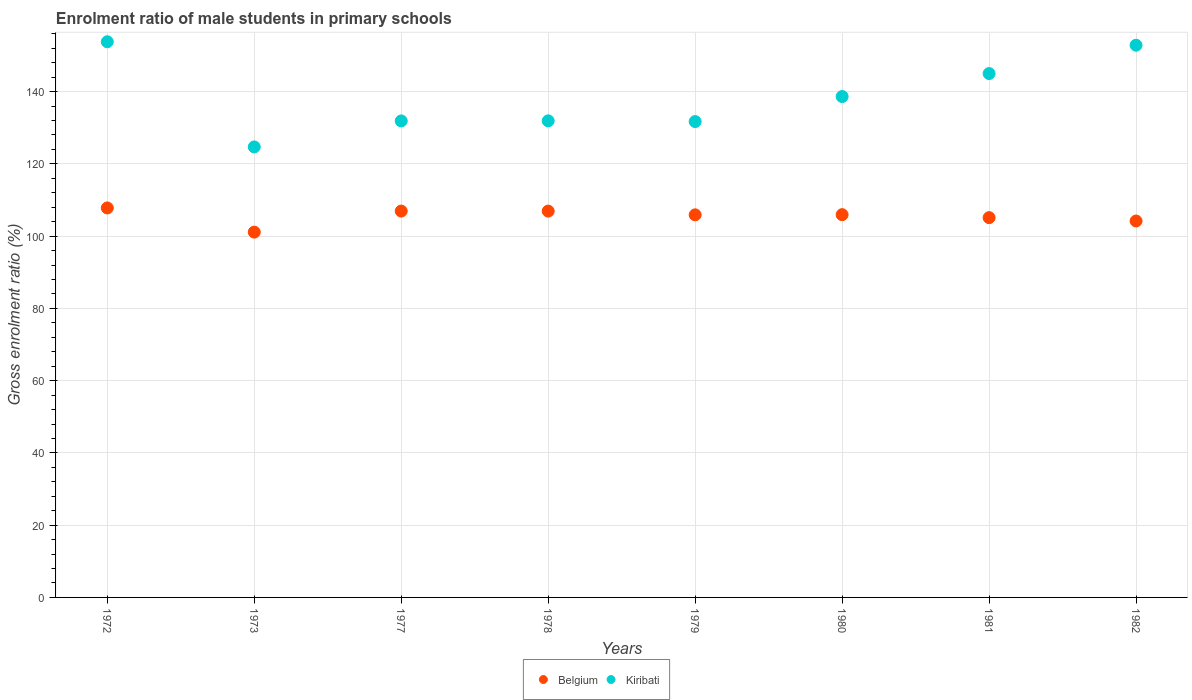How many different coloured dotlines are there?
Offer a very short reply. 2. What is the enrolment ratio of male students in primary schools in Belgium in 1980?
Your answer should be compact. 105.94. Across all years, what is the maximum enrolment ratio of male students in primary schools in Kiribati?
Your response must be concise. 153.8. Across all years, what is the minimum enrolment ratio of male students in primary schools in Belgium?
Keep it short and to the point. 101.11. In which year was the enrolment ratio of male students in primary schools in Belgium minimum?
Your response must be concise. 1973. What is the total enrolment ratio of male students in primary schools in Kiribati in the graph?
Make the answer very short. 1110.47. What is the difference between the enrolment ratio of male students in primary schools in Belgium in 1978 and that in 1980?
Ensure brevity in your answer.  0.99. What is the difference between the enrolment ratio of male students in primary schools in Kiribati in 1979 and the enrolment ratio of male students in primary schools in Belgium in 1981?
Keep it short and to the point. 26.59. What is the average enrolment ratio of male students in primary schools in Kiribati per year?
Your response must be concise. 138.81. In the year 1978, what is the difference between the enrolment ratio of male students in primary schools in Belgium and enrolment ratio of male students in primary schools in Kiribati?
Make the answer very short. -24.98. What is the ratio of the enrolment ratio of male students in primary schools in Kiribati in 1972 to that in 1973?
Provide a succinct answer. 1.23. What is the difference between the highest and the second highest enrolment ratio of male students in primary schools in Kiribati?
Offer a terse response. 0.95. What is the difference between the highest and the lowest enrolment ratio of male students in primary schools in Kiribati?
Make the answer very short. 29.11. In how many years, is the enrolment ratio of male students in primary schools in Belgium greater than the average enrolment ratio of male students in primary schools in Belgium taken over all years?
Your answer should be compact. 5. Is the sum of the enrolment ratio of male students in primary schools in Belgium in 1980 and 1981 greater than the maximum enrolment ratio of male students in primary schools in Kiribati across all years?
Offer a very short reply. Yes. Does the enrolment ratio of male students in primary schools in Belgium monotonically increase over the years?
Provide a short and direct response. No. Is the enrolment ratio of male students in primary schools in Belgium strictly greater than the enrolment ratio of male students in primary schools in Kiribati over the years?
Your response must be concise. No. Are the values on the major ticks of Y-axis written in scientific E-notation?
Make the answer very short. No. How many legend labels are there?
Your response must be concise. 2. What is the title of the graph?
Keep it short and to the point. Enrolment ratio of male students in primary schools. What is the label or title of the X-axis?
Provide a short and direct response. Years. What is the label or title of the Y-axis?
Keep it short and to the point. Gross enrolment ratio (%). What is the Gross enrolment ratio (%) in Belgium in 1972?
Provide a short and direct response. 107.8. What is the Gross enrolment ratio (%) in Kiribati in 1972?
Provide a succinct answer. 153.8. What is the Gross enrolment ratio (%) in Belgium in 1973?
Offer a very short reply. 101.11. What is the Gross enrolment ratio (%) of Kiribati in 1973?
Your answer should be compact. 124.69. What is the Gross enrolment ratio (%) of Belgium in 1977?
Ensure brevity in your answer.  106.93. What is the Gross enrolment ratio (%) of Kiribati in 1977?
Give a very brief answer. 131.89. What is the Gross enrolment ratio (%) of Belgium in 1978?
Offer a terse response. 106.92. What is the Gross enrolment ratio (%) of Kiribati in 1978?
Your answer should be very brief. 131.91. What is the Gross enrolment ratio (%) in Belgium in 1979?
Your answer should be very brief. 105.89. What is the Gross enrolment ratio (%) of Kiribati in 1979?
Provide a short and direct response. 131.71. What is the Gross enrolment ratio (%) of Belgium in 1980?
Give a very brief answer. 105.94. What is the Gross enrolment ratio (%) in Kiribati in 1980?
Ensure brevity in your answer.  138.64. What is the Gross enrolment ratio (%) of Belgium in 1981?
Keep it short and to the point. 105.12. What is the Gross enrolment ratio (%) of Kiribati in 1981?
Give a very brief answer. 145. What is the Gross enrolment ratio (%) of Belgium in 1982?
Provide a succinct answer. 104.19. What is the Gross enrolment ratio (%) of Kiribati in 1982?
Your answer should be very brief. 152.84. Across all years, what is the maximum Gross enrolment ratio (%) in Belgium?
Your response must be concise. 107.8. Across all years, what is the maximum Gross enrolment ratio (%) of Kiribati?
Your response must be concise. 153.8. Across all years, what is the minimum Gross enrolment ratio (%) of Belgium?
Make the answer very short. 101.11. Across all years, what is the minimum Gross enrolment ratio (%) of Kiribati?
Make the answer very short. 124.69. What is the total Gross enrolment ratio (%) in Belgium in the graph?
Offer a very short reply. 843.91. What is the total Gross enrolment ratio (%) of Kiribati in the graph?
Make the answer very short. 1110.47. What is the difference between the Gross enrolment ratio (%) in Belgium in 1972 and that in 1973?
Offer a very short reply. 6.69. What is the difference between the Gross enrolment ratio (%) in Kiribati in 1972 and that in 1973?
Give a very brief answer. 29.11. What is the difference between the Gross enrolment ratio (%) of Belgium in 1972 and that in 1977?
Offer a terse response. 0.87. What is the difference between the Gross enrolment ratio (%) in Kiribati in 1972 and that in 1977?
Give a very brief answer. 21.91. What is the difference between the Gross enrolment ratio (%) of Belgium in 1972 and that in 1978?
Provide a short and direct response. 0.88. What is the difference between the Gross enrolment ratio (%) of Kiribati in 1972 and that in 1978?
Provide a short and direct response. 21.89. What is the difference between the Gross enrolment ratio (%) of Belgium in 1972 and that in 1979?
Keep it short and to the point. 1.91. What is the difference between the Gross enrolment ratio (%) of Kiribati in 1972 and that in 1979?
Ensure brevity in your answer.  22.09. What is the difference between the Gross enrolment ratio (%) in Belgium in 1972 and that in 1980?
Your answer should be very brief. 1.86. What is the difference between the Gross enrolment ratio (%) in Kiribati in 1972 and that in 1980?
Your answer should be very brief. 15.16. What is the difference between the Gross enrolment ratio (%) in Belgium in 1972 and that in 1981?
Your answer should be very brief. 2.68. What is the difference between the Gross enrolment ratio (%) in Kiribati in 1972 and that in 1981?
Your answer should be very brief. 8.8. What is the difference between the Gross enrolment ratio (%) in Belgium in 1972 and that in 1982?
Ensure brevity in your answer.  3.61. What is the difference between the Gross enrolment ratio (%) in Belgium in 1973 and that in 1977?
Your answer should be very brief. -5.82. What is the difference between the Gross enrolment ratio (%) of Kiribati in 1973 and that in 1977?
Provide a succinct answer. -7.2. What is the difference between the Gross enrolment ratio (%) of Belgium in 1973 and that in 1978?
Provide a short and direct response. -5.81. What is the difference between the Gross enrolment ratio (%) in Kiribati in 1973 and that in 1978?
Ensure brevity in your answer.  -7.22. What is the difference between the Gross enrolment ratio (%) of Belgium in 1973 and that in 1979?
Give a very brief answer. -4.78. What is the difference between the Gross enrolment ratio (%) in Kiribati in 1973 and that in 1979?
Ensure brevity in your answer.  -7.02. What is the difference between the Gross enrolment ratio (%) of Belgium in 1973 and that in 1980?
Your answer should be compact. -4.83. What is the difference between the Gross enrolment ratio (%) of Kiribati in 1973 and that in 1980?
Your answer should be very brief. -13.95. What is the difference between the Gross enrolment ratio (%) of Belgium in 1973 and that in 1981?
Make the answer very short. -4.01. What is the difference between the Gross enrolment ratio (%) of Kiribati in 1973 and that in 1981?
Your response must be concise. -20.31. What is the difference between the Gross enrolment ratio (%) in Belgium in 1973 and that in 1982?
Your response must be concise. -3.08. What is the difference between the Gross enrolment ratio (%) in Kiribati in 1973 and that in 1982?
Offer a terse response. -28.15. What is the difference between the Gross enrolment ratio (%) of Belgium in 1977 and that in 1978?
Your response must be concise. 0.01. What is the difference between the Gross enrolment ratio (%) of Kiribati in 1977 and that in 1978?
Offer a terse response. -0.02. What is the difference between the Gross enrolment ratio (%) in Belgium in 1977 and that in 1979?
Give a very brief answer. 1.04. What is the difference between the Gross enrolment ratio (%) in Kiribati in 1977 and that in 1979?
Ensure brevity in your answer.  0.18. What is the difference between the Gross enrolment ratio (%) of Belgium in 1977 and that in 1980?
Your answer should be very brief. 1. What is the difference between the Gross enrolment ratio (%) in Kiribati in 1977 and that in 1980?
Give a very brief answer. -6.75. What is the difference between the Gross enrolment ratio (%) in Belgium in 1977 and that in 1981?
Your answer should be compact. 1.82. What is the difference between the Gross enrolment ratio (%) in Kiribati in 1977 and that in 1981?
Provide a short and direct response. -13.11. What is the difference between the Gross enrolment ratio (%) of Belgium in 1977 and that in 1982?
Provide a short and direct response. 2.74. What is the difference between the Gross enrolment ratio (%) in Kiribati in 1977 and that in 1982?
Your answer should be very brief. -20.95. What is the difference between the Gross enrolment ratio (%) in Belgium in 1978 and that in 1979?
Make the answer very short. 1.03. What is the difference between the Gross enrolment ratio (%) of Kiribati in 1978 and that in 1979?
Provide a succinct answer. 0.2. What is the difference between the Gross enrolment ratio (%) of Kiribati in 1978 and that in 1980?
Your answer should be very brief. -6.73. What is the difference between the Gross enrolment ratio (%) in Belgium in 1978 and that in 1981?
Offer a terse response. 1.81. What is the difference between the Gross enrolment ratio (%) of Kiribati in 1978 and that in 1981?
Your answer should be very brief. -13.09. What is the difference between the Gross enrolment ratio (%) of Belgium in 1978 and that in 1982?
Your answer should be very brief. 2.73. What is the difference between the Gross enrolment ratio (%) in Kiribati in 1978 and that in 1982?
Your response must be concise. -20.93. What is the difference between the Gross enrolment ratio (%) of Belgium in 1979 and that in 1980?
Your answer should be compact. -0.05. What is the difference between the Gross enrolment ratio (%) in Kiribati in 1979 and that in 1980?
Give a very brief answer. -6.93. What is the difference between the Gross enrolment ratio (%) in Belgium in 1979 and that in 1981?
Ensure brevity in your answer.  0.78. What is the difference between the Gross enrolment ratio (%) in Kiribati in 1979 and that in 1981?
Provide a short and direct response. -13.29. What is the difference between the Gross enrolment ratio (%) in Belgium in 1979 and that in 1982?
Provide a succinct answer. 1.7. What is the difference between the Gross enrolment ratio (%) of Kiribati in 1979 and that in 1982?
Your answer should be very brief. -21.13. What is the difference between the Gross enrolment ratio (%) of Belgium in 1980 and that in 1981?
Keep it short and to the point. 0.82. What is the difference between the Gross enrolment ratio (%) of Kiribati in 1980 and that in 1981?
Your answer should be very brief. -6.36. What is the difference between the Gross enrolment ratio (%) in Belgium in 1980 and that in 1982?
Make the answer very short. 1.75. What is the difference between the Gross enrolment ratio (%) of Kiribati in 1980 and that in 1982?
Your response must be concise. -14.21. What is the difference between the Gross enrolment ratio (%) of Belgium in 1981 and that in 1982?
Your response must be concise. 0.93. What is the difference between the Gross enrolment ratio (%) in Kiribati in 1981 and that in 1982?
Your response must be concise. -7.85. What is the difference between the Gross enrolment ratio (%) in Belgium in 1972 and the Gross enrolment ratio (%) in Kiribati in 1973?
Offer a terse response. -16.89. What is the difference between the Gross enrolment ratio (%) in Belgium in 1972 and the Gross enrolment ratio (%) in Kiribati in 1977?
Provide a succinct answer. -24.09. What is the difference between the Gross enrolment ratio (%) in Belgium in 1972 and the Gross enrolment ratio (%) in Kiribati in 1978?
Ensure brevity in your answer.  -24.11. What is the difference between the Gross enrolment ratio (%) in Belgium in 1972 and the Gross enrolment ratio (%) in Kiribati in 1979?
Offer a very short reply. -23.91. What is the difference between the Gross enrolment ratio (%) in Belgium in 1972 and the Gross enrolment ratio (%) in Kiribati in 1980?
Give a very brief answer. -30.84. What is the difference between the Gross enrolment ratio (%) of Belgium in 1972 and the Gross enrolment ratio (%) of Kiribati in 1981?
Your response must be concise. -37.2. What is the difference between the Gross enrolment ratio (%) of Belgium in 1972 and the Gross enrolment ratio (%) of Kiribati in 1982?
Provide a succinct answer. -45.04. What is the difference between the Gross enrolment ratio (%) of Belgium in 1973 and the Gross enrolment ratio (%) of Kiribati in 1977?
Your answer should be very brief. -30.78. What is the difference between the Gross enrolment ratio (%) of Belgium in 1973 and the Gross enrolment ratio (%) of Kiribati in 1978?
Ensure brevity in your answer.  -30.8. What is the difference between the Gross enrolment ratio (%) in Belgium in 1973 and the Gross enrolment ratio (%) in Kiribati in 1979?
Give a very brief answer. -30.6. What is the difference between the Gross enrolment ratio (%) of Belgium in 1973 and the Gross enrolment ratio (%) of Kiribati in 1980?
Keep it short and to the point. -37.53. What is the difference between the Gross enrolment ratio (%) of Belgium in 1973 and the Gross enrolment ratio (%) of Kiribati in 1981?
Keep it short and to the point. -43.89. What is the difference between the Gross enrolment ratio (%) in Belgium in 1973 and the Gross enrolment ratio (%) in Kiribati in 1982?
Provide a short and direct response. -51.73. What is the difference between the Gross enrolment ratio (%) of Belgium in 1977 and the Gross enrolment ratio (%) of Kiribati in 1978?
Offer a very short reply. -24.97. What is the difference between the Gross enrolment ratio (%) in Belgium in 1977 and the Gross enrolment ratio (%) in Kiribati in 1979?
Your answer should be very brief. -24.78. What is the difference between the Gross enrolment ratio (%) of Belgium in 1977 and the Gross enrolment ratio (%) of Kiribati in 1980?
Provide a succinct answer. -31.7. What is the difference between the Gross enrolment ratio (%) of Belgium in 1977 and the Gross enrolment ratio (%) of Kiribati in 1981?
Ensure brevity in your answer.  -38.06. What is the difference between the Gross enrolment ratio (%) of Belgium in 1977 and the Gross enrolment ratio (%) of Kiribati in 1982?
Offer a terse response. -45.91. What is the difference between the Gross enrolment ratio (%) of Belgium in 1978 and the Gross enrolment ratio (%) of Kiribati in 1979?
Make the answer very short. -24.79. What is the difference between the Gross enrolment ratio (%) in Belgium in 1978 and the Gross enrolment ratio (%) in Kiribati in 1980?
Keep it short and to the point. -31.71. What is the difference between the Gross enrolment ratio (%) of Belgium in 1978 and the Gross enrolment ratio (%) of Kiribati in 1981?
Provide a short and direct response. -38.07. What is the difference between the Gross enrolment ratio (%) in Belgium in 1978 and the Gross enrolment ratio (%) in Kiribati in 1982?
Your response must be concise. -45.92. What is the difference between the Gross enrolment ratio (%) of Belgium in 1979 and the Gross enrolment ratio (%) of Kiribati in 1980?
Provide a short and direct response. -32.74. What is the difference between the Gross enrolment ratio (%) of Belgium in 1979 and the Gross enrolment ratio (%) of Kiribati in 1981?
Give a very brief answer. -39.1. What is the difference between the Gross enrolment ratio (%) of Belgium in 1979 and the Gross enrolment ratio (%) of Kiribati in 1982?
Provide a short and direct response. -46.95. What is the difference between the Gross enrolment ratio (%) in Belgium in 1980 and the Gross enrolment ratio (%) in Kiribati in 1981?
Offer a very short reply. -39.06. What is the difference between the Gross enrolment ratio (%) of Belgium in 1980 and the Gross enrolment ratio (%) of Kiribati in 1982?
Ensure brevity in your answer.  -46.9. What is the difference between the Gross enrolment ratio (%) in Belgium in 1981 and the Gross enrolment ratio (%) in Kiribati in 1982?
Your response must be concise. -47.72. What is the average Gross enrolment ratio (%) of Belgium per year?
Provide a succinct answer. 105.49. What is the average Gross enrolment ratio (%) of Kiribati per year?
Give a very brief answer. 138.81. In the year 1972, what is the difference between the Gross enrolment ratio (%) of Belgium and Gross enrolment ratio (%) of Kiribati?
Your answer should be very brief. -46. In the year 1973, what is the difference between the Gross enrolment ratio (%) in Belgium and Gross enrolment ratio (%) in Kiribati?
Offer a very short reply. -23.58. In the year 1977, what is the difference between the Gross enrolment ratio (%) in Belgium and Gross enrolment ratio (%) in Kiribati?
Ensure brevity in your answer.  -24.96. In the year 1978, what is the difference between the Gross enrolment ratio (%) of Belgium and Gross enrolment ratio (%) of Kiribati?
Give a very brief answer. -24.98. In the year 1979, what is the difference between the Gross enrolment ratio (%) in Belgium and Gross enrolment ratio (%) in Kiribati?
Your answer should be very brief. -25.82. In the year 1980, what is the difference between the Gross enrolment ratio (%) of Belgium and Gross enrolment ratio (%) of Kiribati?
Give a very brief answer. -32.7. In the year 1981, what is the difference between the Gross enrolment ratio (%) in Belgium and Gross enrolment ratio (%) in Kiribati?
Offer a very short reply. -39.88. In the year 1982, what is the difference between the Gross enrolment ratio (%) in Belgium and Gross enrolment ratio (%) in Kiribati?
Make the answer very short. -48.65. What is the ratio of the Gross enrolment ratio (%) in Belgium in 1972 to that in 1973?
Your response must be concise. 1.07. What is the ratio of the Gross enrolment ratio (%) in Kiribati in 1972 to that in 1973?
Provide a short and direct response. 1.23. What is the ratio of the Gross enrolment ratio (%) of Belgium in 1972 to that in 1977?
Your response must be concise. 1.01. What is the ratio of the Gross enrolment ratio (%) in Kiribati in 1972 to that in 1977?
Make the answer very short. 1.17. What is the ratio of the Gross enrolment ratio (%) in Belgium in 1972 to that in 1978?
Ensure brevity in your answer.  1.01. What is the ratio of the Gross enrolment ratio (%) in Kiribati in 1972 to that in 1978?
Provide a short and direct response. 1.17. What is the ratio of the Gross enrolment ratio (%) in Kiribati in 1972 to that in 1979?
Offer a terse response. 1.17. What is the ratio of the Gross enrolment ratio (%) in Belgium in 1972 to that in 1980?
Provide a short and direct response. 1.02. What is the ratio of the Gross enrolment ratio (%) in Kiribati in 1972 to that in 1980?
Offer a terse response. 1.11. What is the ratio of the Gross enrolment ratio (%) in Belgium in 1972 to that in 1981?
Ensure brevity in your answer.  1.03. What is the ratio of the Gross enrolment ratio (%) in Kiribati in 1972 to that in 1981?
Give a very brief answer. 1.06. What is the ratio of the Gross enrolment ratio (%) in Belgium in 1972 to that in 1982?
Keep it short and to the point. 1.03. What is the ratio of the Gross enrolment ratio (%) of Belgium in 1973 to that in 1977?
Ensure brevity in your answer.  0.95. What is the ratio of the Gross enrolment ratio (%) of Kiribati in 1973 to that in 1977?
Your answer should be compact. 0.95. What is the ratio of the Gross enrolment ratio (%) in Belgium in 1973 to that in 1978?
Ensure brevity in your answer.  0.95. What is the ratio of the Gross enrolment ratio (%) in Kiribati in 1973 to that in 1978?
Give a very brief answer. 0.95. What is the ratio of the Gross enrolment ratio (%) of Belgium in 1973 to that in 1979?
Your answer should be compact. 0.95. What is the ratio of the Gross enrolment ratio (%) in Kiribati in 1973 to that in 1979?
Your response must be concise. 0.95. What is the ratio of the Gross enrolment ratio (%) of Belgium in 1973 to that in 1980?
Offer a very short reply. 0.95. What is the ratio of the Gross enrolment ratio (%) of Kiribati in 1973 to that in 1980?
Your response must be concise. 0.9. What is the ratio of the Gross enrolment ratio (%) in Belgium in 1973 to that in 1981?
Your answer should be compact. 0.96. What is the ratio of the Gross enrolment ratio (%) in Kiribati in 1973 to that in 1981?
Make the answer very short. 0.86. What is the ratio of the Gross enrolment ratio (%) of Belgium in 1973 to that in 1982?
Your response must be concise. 0.97. What is the ratio of the Gross enrolment ratio (%) of Kiribati in 1973 to that in 1982?
Your answer should be very brief. 0.82. What is the ratio of the Gross enrolment ratio (%) in Belgium in 1977 to that in 1978?
Keep it short and to the point. 1. What is the ratio of the Gross enrolment ratio (%) of Kiribati in 1977 to that in 1978?
Your answer should be very brief. 1. What is the ratio of the Gross enrolment ratio (%) of Belgium in 1977 to that in 1979?
Offer a very short reply. 1.01. What is the ratio of the Gross enrolment ratio (%) of Kiribati in 1977 to that in 1979?
Give a very brief answer. 1. What is the ratio of the Gross enrolment ratio (%) of Belgium in 1977 to that in 1980?
Provide a succinct answer. 1.01. What is the ratio of the Gross enrolment ratio (%) in Kiribati in 1977 to that in 1980?
Your answer should be very brief. 0.95. What is the ratio of the Gross enrolment ratio (%) of Belgium in 1977 to that in 1981?
Your answer should be compact. 1.02. What is the ratio of the Gross enrolment ratio (%) in Kiribati in 1977 to that in 1981?
Make the answer very short. 0.91. What is the ratio of the Gross enrolment ratio (%) in Belgium in 1977 to that in 1982?
Ensure brevity in your answer.  1.03. What is the ratio of the Gross enrolment ratio (%) of Kiribati in 1977 to that in 1982?
Your answer should be compact. 0.86. What is the ratio of the Gross enrolment ratio (%) in Belgium in 1978 to that in 1979?
Provide a succinct answer. 1.01. What is the ratio of the Gross enrolment ratio (%) in Kiribati in 1978 to that in 1979?
Your response must be concise. 1. What is the ratio of the Gross enrolment ratio (%) in Belgium in 1978 to that in 1980?
Your answer should be very brief. 1.01. What is the ratio of the Gross enrolment ratio (%) of Kiribati in 1978 to that in 1980?
Offer a very short reply. 0.95. What is the ratio of the Gross enrolment ratio (%) of Belgium in 1978 to that in 1981?
Keep it short and to the point. 1.02. What is the ratio of the Gross enrolment ratio (%) in Kiribati in 1978 to that in 1981?
Provide a short and direct response. 0.91. What is the ratio of the Gross enrolment ratio (%) in Belgium in 1978 to that in 1982?
Your response must be concise. 1.03. What is the ratio of the Gross enrolment ratio (%) in Kiribati in 1978 to that in 1982?
Your response must be concise. 0.86. What is the ratio of the Gross enrolment ratio (%) of Belgium in 1979 to that in 1981?
Your answer should be very brief. 1.01. What is the ratio of the Gross enrolment ratio (%) in Kiribati in 1979 to that in 1981?
Your answer should be compact. 0.91. What is the ratio of the Gross enrolment ratio (%) in Belgium in 1979 to that in 1982?
Give a very brief answer. 1.02. What is the ratio of the Gross enrolment ratio (%) in Kiribati in 1979 to that in 1982?
Provide a succinct answer. 0.86. What is the ratio of the Gross enrolment ratio (%) of Kiribati in 1980 to that in 1981?
Your response must be concise. 0.96. What is the ratio of the Gross enrolment ratio (%) in Belgium in 1980 to that in 1982?
Make the answer very short. 1.02. What is the ratio of the Gross enrolment ratio (%) in Kiribati in 1980 to that in 1982?
Keep it short and to the point. 0.91. What is the ratio of the Gross enrolment ratio (%) of Belgium in 1981 to that in 1982?
Keep it short and to the point. 1.01. What is the ratio of the Gross enrolment ratio (%) in Kiribati in 1981 to that in 1982?
Provide a short and direct response. 0.95. What is the difference between the highest and the second highest Gross enrolment ratio (%) in Belgium?
Provide a short and direct response. 0.87. What is the difference between the highest and the lowest Gross enrolment ratio (%) in Belgium?
Your response must be concise. 6.69. What is the difference between the highest and the lowest Gross enrolment ratio (%) in Kiribati?
Your response must be concise. 29.11. 